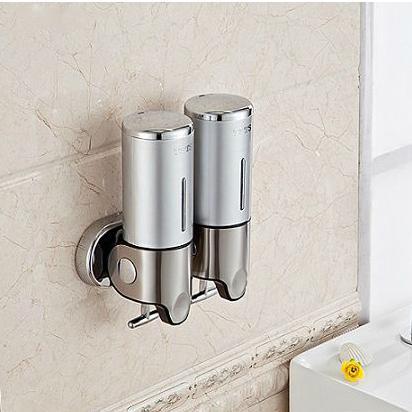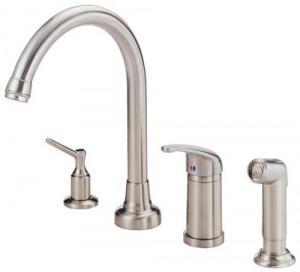The first image is the image on the left, the second image is the image on the right. Assess this claim about the two images: "An image shows one white ceramic-look pump-top dispenser illustrated with a bird likeness.". Correct or not? Answer yes or no. No. 